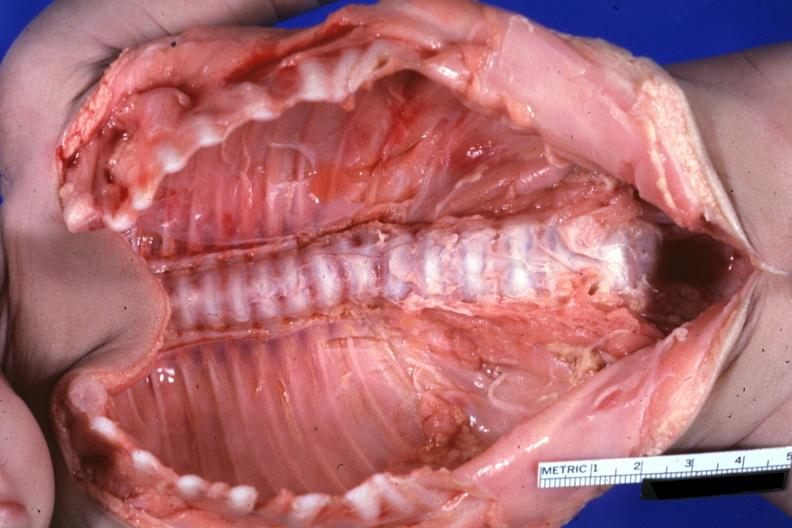does this image show opened body cavity natural color lesion at t12 see protocol?
Answer the question using a single word or phrase. Yes 